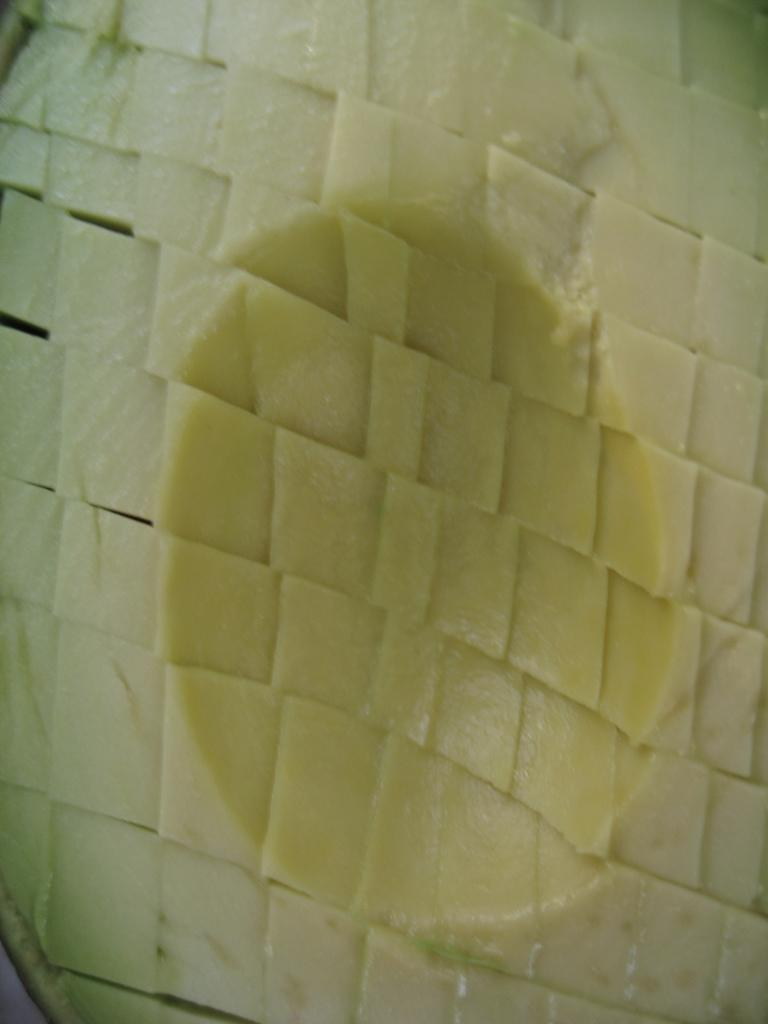What is the main subject of the image? There is a food item in the image. How many ladybugs are riding the bike in the image? There are no ladybugs or bikes present in the image; it only features a food item. 